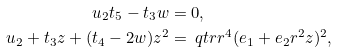<formula> <loc_0><loc_0><loc_500><loc_500>u _ { 2 } t _ { 5 } - t _ { 3 } w & = 0 , \\ u _ { 2 } + t _ { 3 } z + ( t _ { 4 } - 2 w ) z ^ { 2 } & = \ q t r r ^ { 4 } ( e _ { 1 } + e _ { 2 } r ^ { 2 } z ) ^ { 2 } ,</formula> 